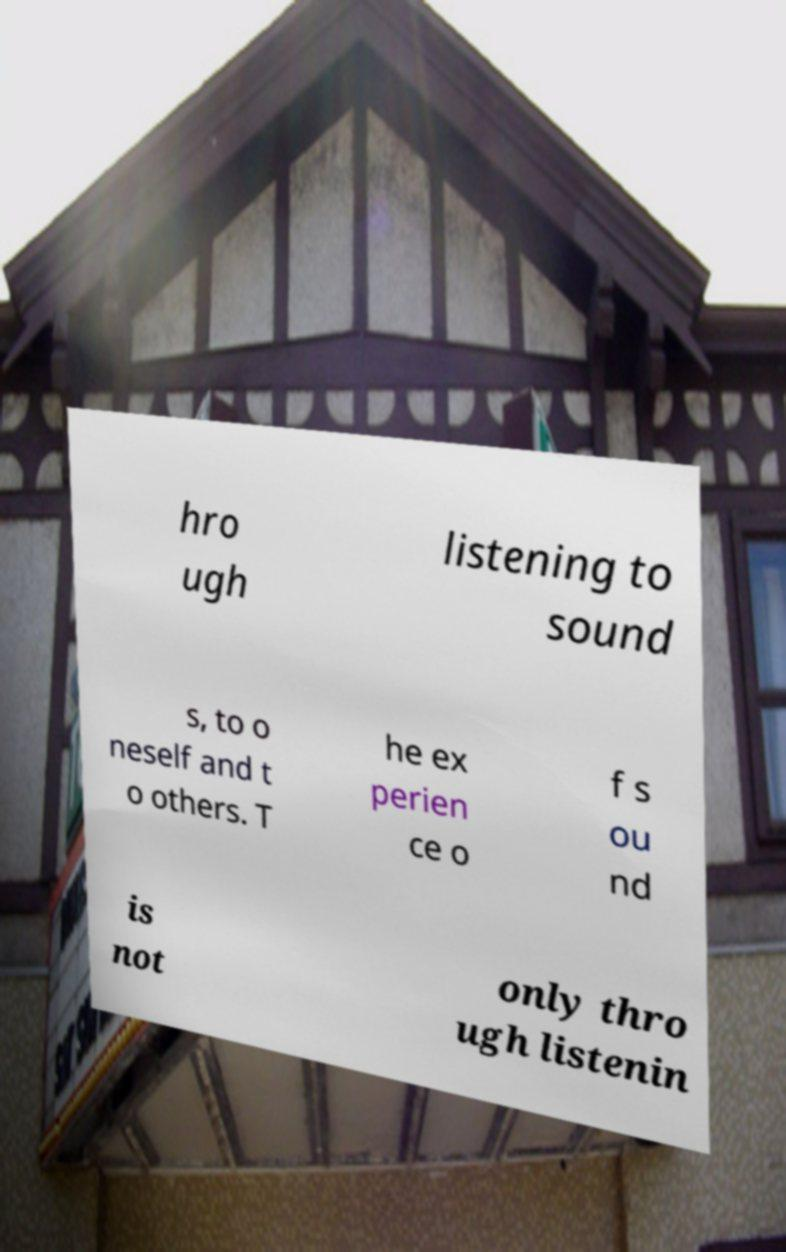Could you extract and type out the text from this image? hro ugh listening to sound s, to o neself and t o others. T he ex perien ce o f s ou nd is not only thro ugh listenin 